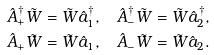<formula> <loc_0><loc_0><loc_500><loc_500>\hat { A } _ { + } ^ { \dag } \tilde { W } & = \tilde { W } \hat { a } _ { 1 } ^ { \dag } , \quad \hat { A } _ { - } ^ { \dag } \tilde { W } = \tilde { W } \hat { a } _ { 2 } ^ { \dag } , \\ \hat { A } _ { + } \tilde { W } & = \tilde { W } \hat { a } _ { 1 } , \quad \hat { A } _ { - } \tilde { W } = \tilde { W } \hat { a } _ { 2 } .</formula> 